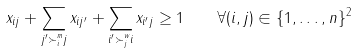<formula> <loc_0><loc_0><loc_500><loc_500>x _ { i j } + \sum _ { j ^ { \prime } \succ ^ { m } _ { i } j } x _ { i j ^ { \prime } } + \sum _ { i ^ { \prime } \succ ^ { w } _ { j } i } x _ { i ^ { \prime } j } \geq 1 \quad \forall ( i , j ) \in \{ 1 , \dots , n \} ^ { 2 }</formula> 